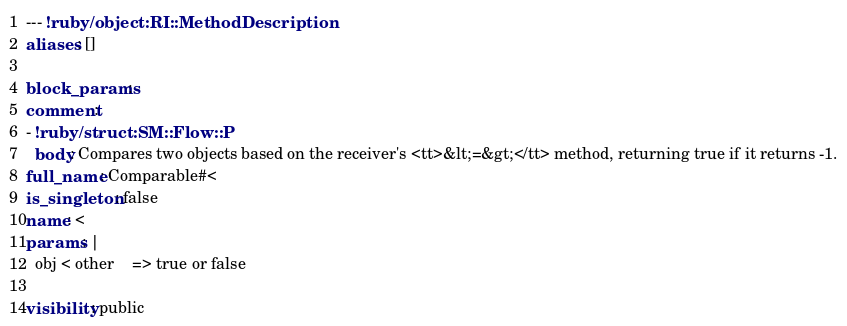Convert code to text. <code><loc_0><loc_0><loc_500><loc_500><_YAML_>--- !ruby/object:RI::MethodDescription 
aliases: []

block_params: 
comment: 
- !ruby/struct:SM::Flow::P 
  body: Compares two objects based on the receiver's <tt>&lt;=&gt;</tt> method, returning true if it returns -1.
full_name: Comparable#<
is_singleton: false
name: <
params: |
  obj < other    => true or false

visibility: public
</code> 